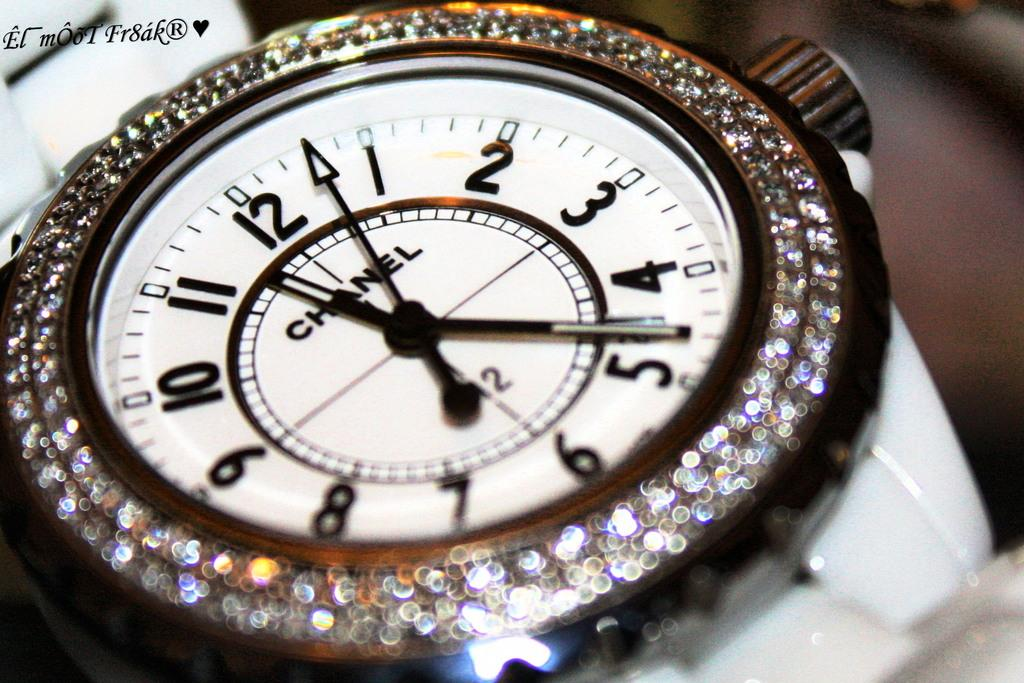<image>
Offer a succinct explanation of the picture presented. a chanel watch has diamonds all around it 